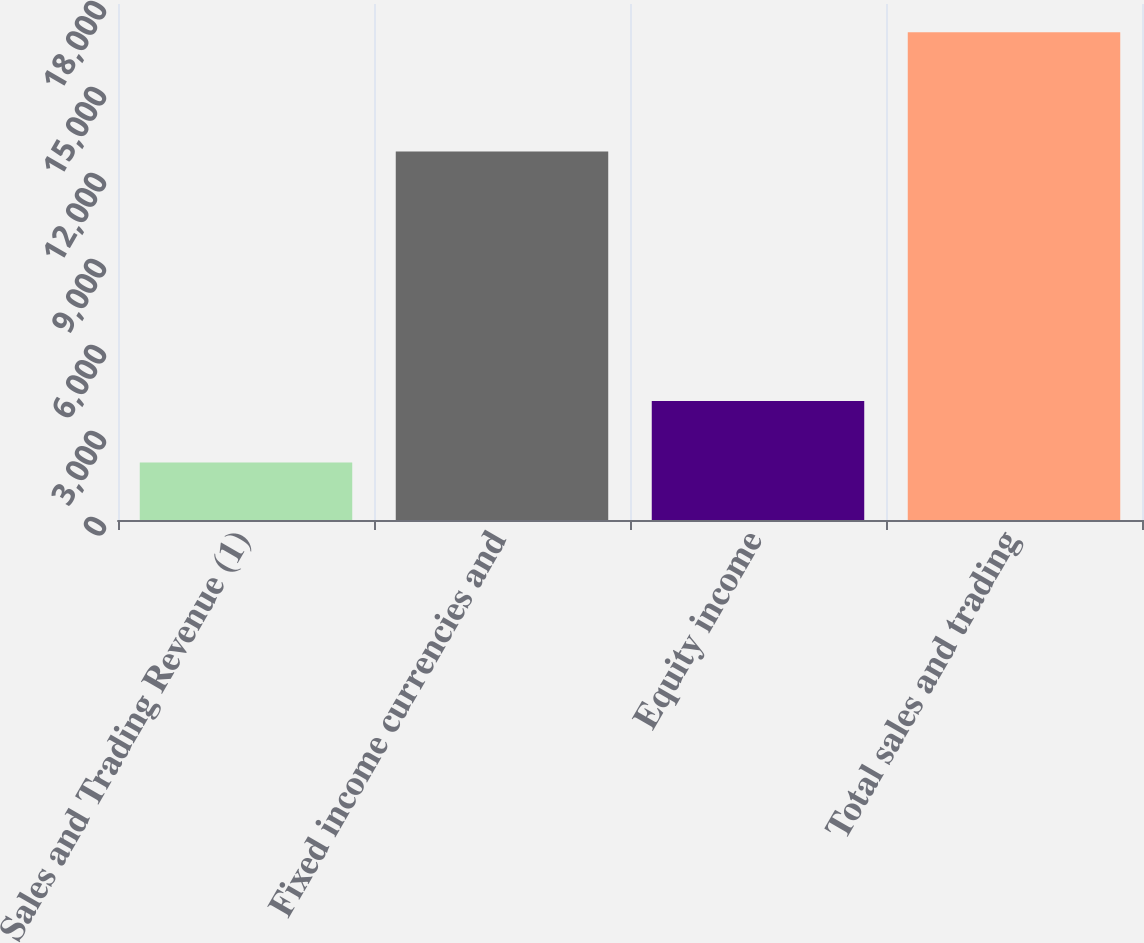<chart> <loc_0><loc_0><loc_500><loc_500><bar_chart><fcel>Sales and Trading Revenue (1)<fcel>Fixed income currencies and<fcel>Equity income<fcel>Total sales and trading<nl><fcel>2010<fcel>12857<fcel>4155<fcel>17012<nl></chart> 